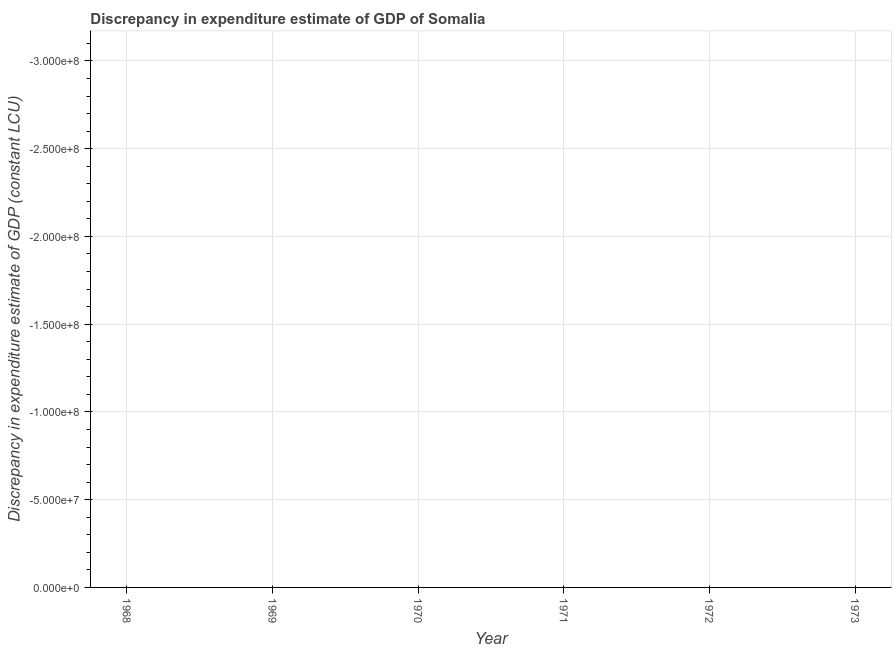What is the discrepancy in expenditure estimate of gdp in 1970?
Provide a short and direct response. 0. Across all years, what is the minimum discrepancy in expenditure estimate of gdp?
Your answer should be compact. 0. What is the sum of the discrepancy in expenditure estimate of gdp?
Offer a terse response. 0. What is the median discrepancy in expenditure estimate of gdp?
Make the answer very short. 0. Does the discrepancy in expenditure estimate of gdp monotonically increase over the years?
Offer a very short reply. No. What is the difference between two consecutive major ticks on the Y-axis?
Offer a very short reply. 5.00e+07. Are the values on the major ticks of Y-axis written in scientific E-notation?
Give a very brief answer. Yes. Does the graph contain any zero values?
Give a very brief answer. Yes. Does the graph contain grids?
Offer a terse response. Yes. What is the title of the graph?
Ensure brevity in your answer.  Discrepancy in expenditure estimate of GDP of Somalia. What is the label or title of the Y-axis?
Offer a very short reply. Discrepancy in expenditure estimate of GDP (constant LCU). What is the Discrepancy in expenditure estimate of GDP (constant LCU) in 1968?
Offer a terse response. 0. What is the Discrepancy in expenditure estimate of GDP (constant LCU) in 1969?
Make the answer very short. 0. What is the Discrepancy in expenditure estimate of GDP (constant LCU) in 1972?
Offer a very short reply. 0. What is the Discrepancy in expenditure estimate of GDP (constant LCU) in 1973?
Make the answer very short. 0. 